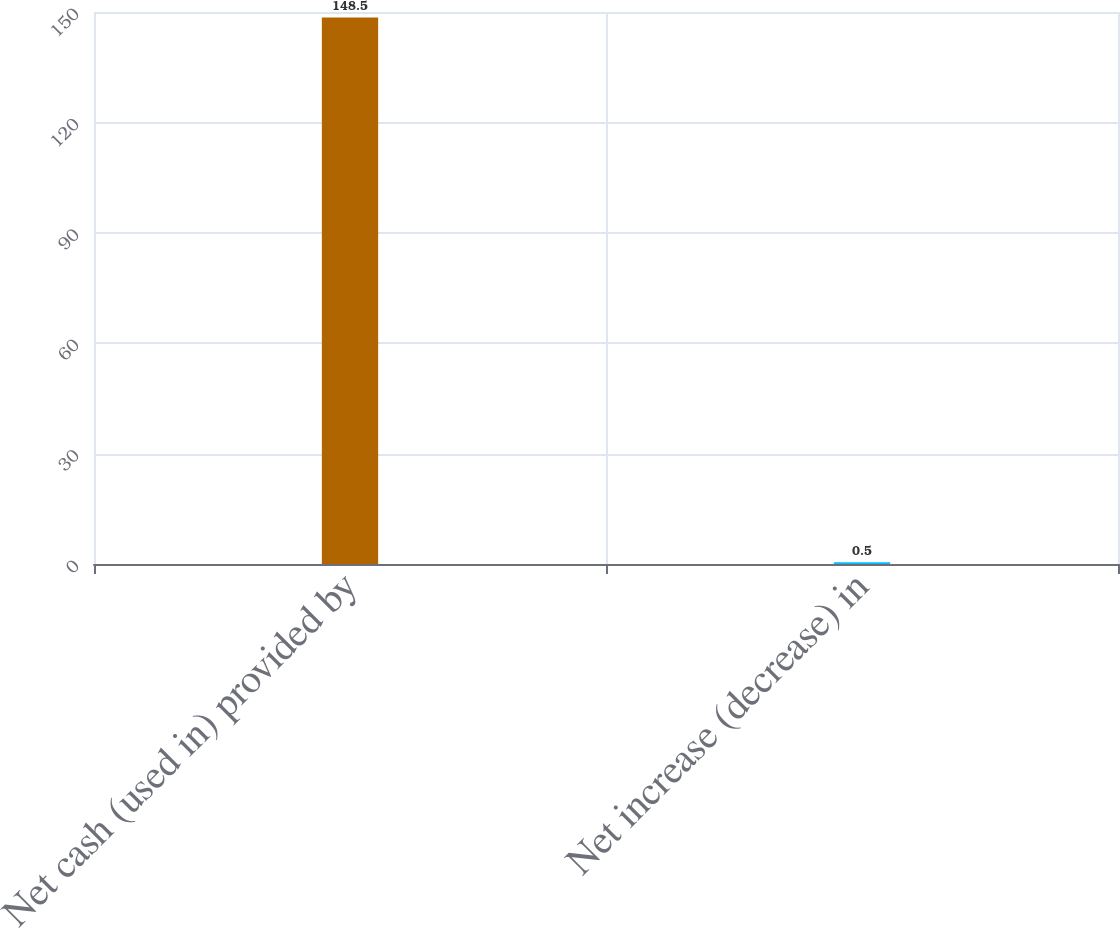Convert chart. <chart><loc_0><loc_0><loc_500><loc_500><bar_chart><fcel>Net cash (used in) provided by<fcel>Net increase (decrease) in<nl><fcel>148.5<fcel>0.5<nl></chart> 